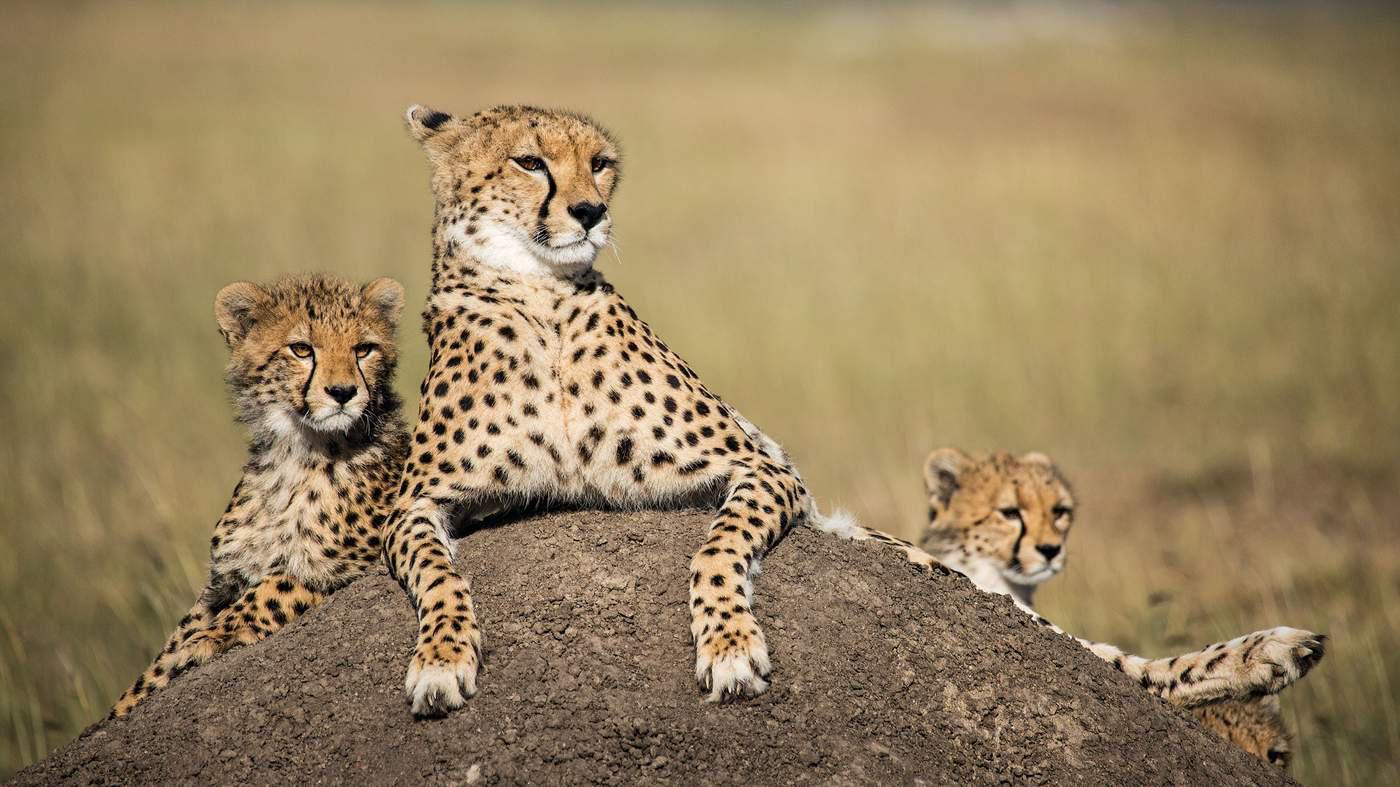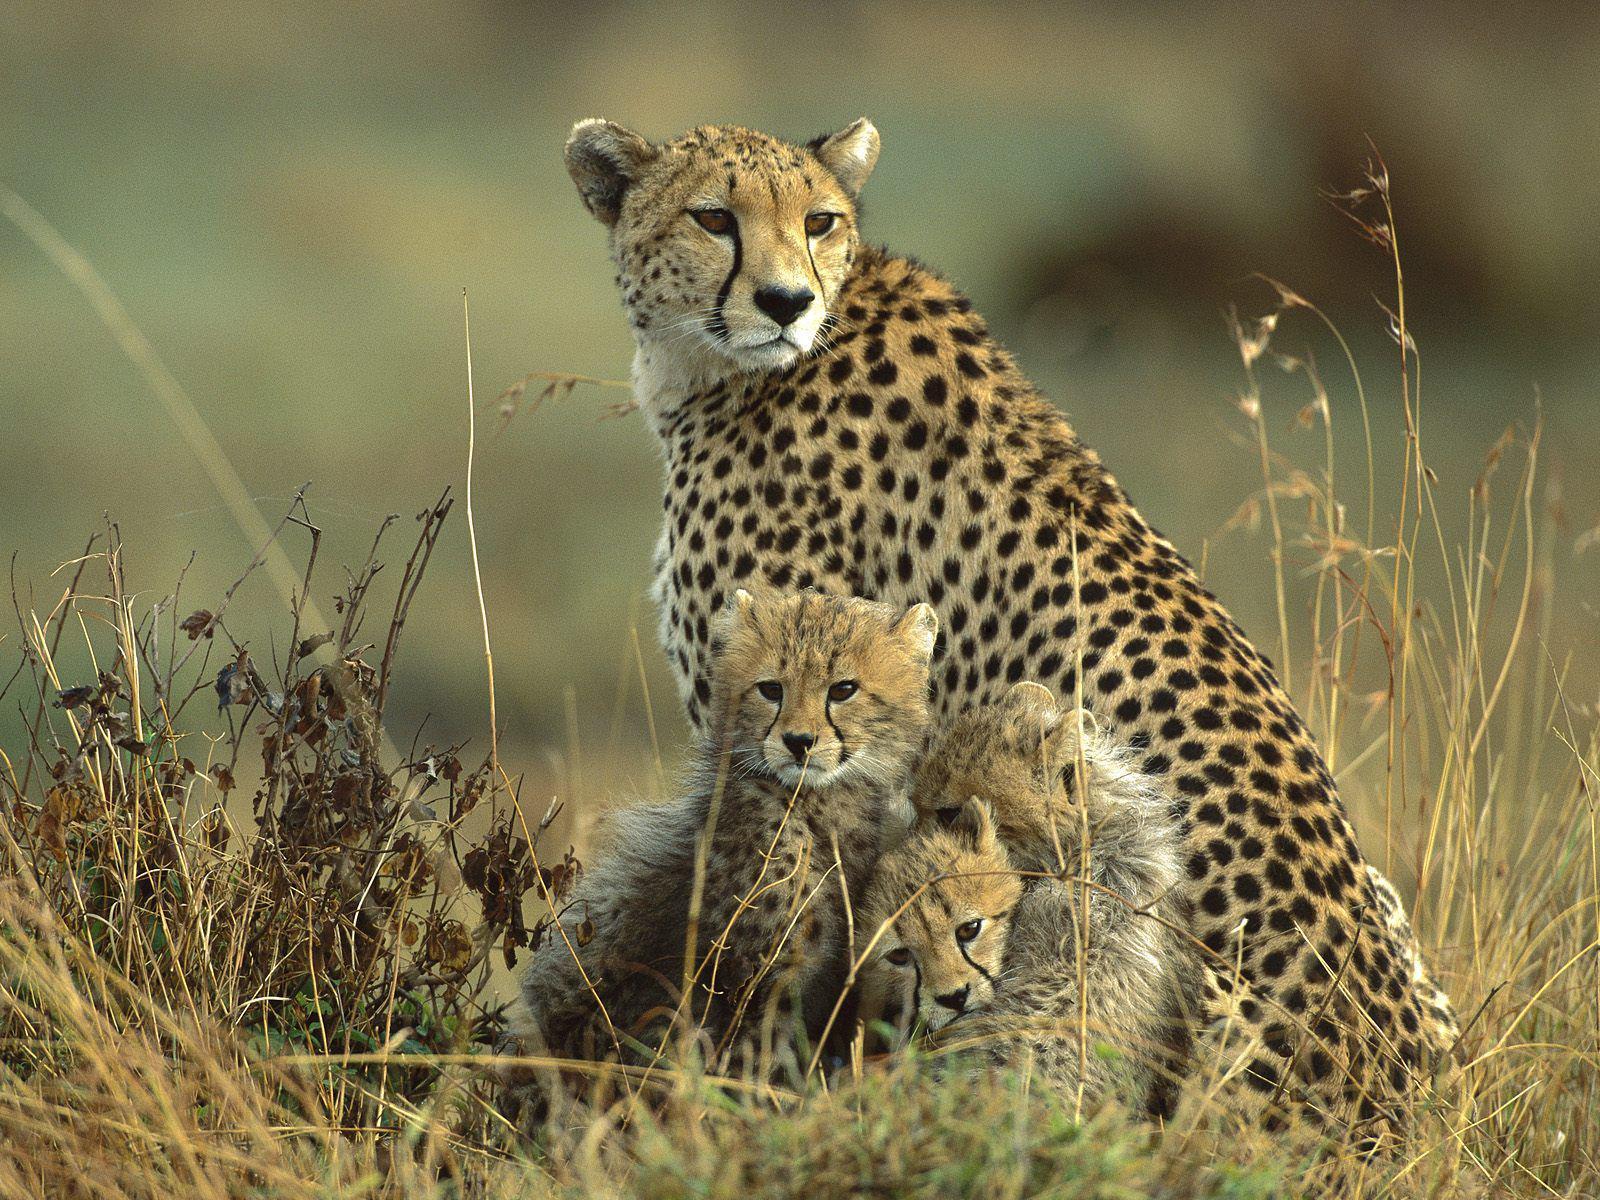The first image is the image on the left, the second image is the image on the right. Given the left and right images, does the statement "At least one cheetah is laying down." hold true? Answer yes or no. Yes. 